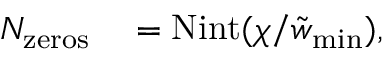<formula> <loc_0><loc_0><loc_500><loc_500>\begin{array} { r l } { N _ { z e r o s } } & = N i n t ( \chi / \tilde { w } _ { \min } ) , } \end{array}</formula> 